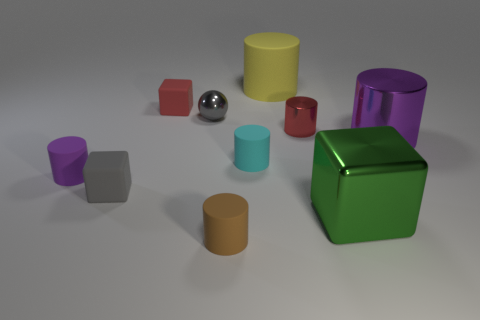What is the shape of the object that is the same color as the small shiny sphere?
Provide a succinct answer. Cube. What number of rubber objects are cyan things or large green cylinders?
Provide a succinct answer. 1. There is a small rubber block in front of the metallic cylinder that is on the left side of the large green thing that is in front of the large yellow cylinder; what color is it?
Make the answer very short. Gray. There is a big metal object that is the same shape as the purple rubber object; what is its color?
Provide a short and direct response. Purple. Is there anything else that is the same color as the shiny cube?
Your response must be concise. No. What number of other objects are there of the same material as the small red cube?
Provide a short and direct response. 5. The cyan rubber thing has what size?
Offer a terse response. Small. Is there a big green thing that has the same shape as the gray rubber object?
Offer a very short reply. Yes. How many things are gray metallic objects or things behind the tiny purple object?
Your answer should be compact. 6. The shiny thing that is in front of the big purple shiny thing is what color?
Provide a short and direct response. Green. 